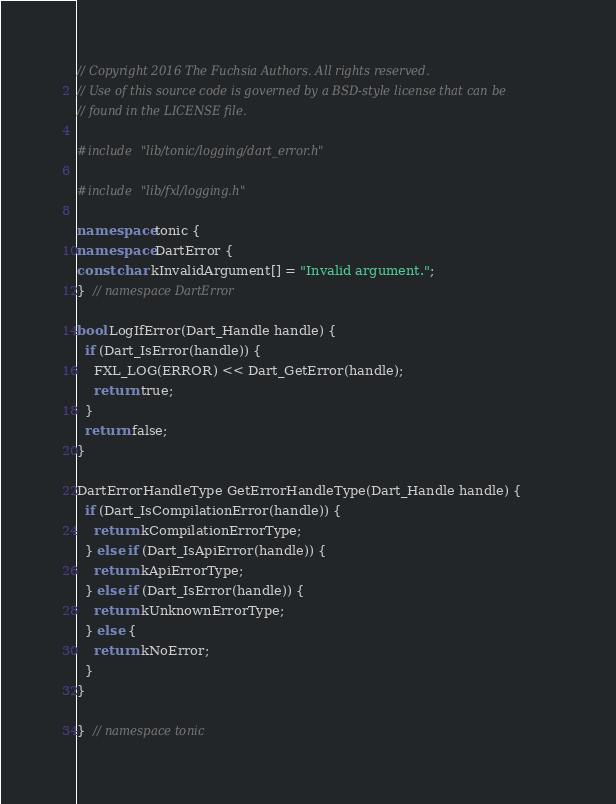<code> <loc_0><loc_0><loc_500><loc_500><_C++_>// Copyright 2016 The Fuchsia Authors. All rights reserved.
// Use of this source code is governed by a BSD-style license that can be
// found in the LICENSE file.

#include "lib/tonic/logging/dart_error.h"

#include "lib/fxl/logging.h"

namespace tonic {
namespace DartError {
const char kInvalidArgument[] = "Invalid argument.";
}  // namespace DartError

bool LogIfError(Dart_Handle handle) {
  if (Dart_IsError(handle)) {
    FXL_LOG(ERROR) << Dart_GetError(handle);
    return true;
  }
  return false;
}

DartErrorHandleType GetErrorHandleType(Dart_Handle handle) {
  if (Dart_IsCompilationError(handle)) {
    return kCompilationErrorType;
  } else if (Dart_IsApiError(handle)) {
    return kApiErrorType;
  } else if (Dart_IsError(handle)) {
    return kUnknownErrorType;
  } else {
    return kNoError;
  }
}

}  // namespace tonic
</code> 